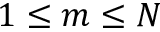<formula> <loc_0><loc_0><loc_500><loc_500>1 \leq m \leq N</formula> 